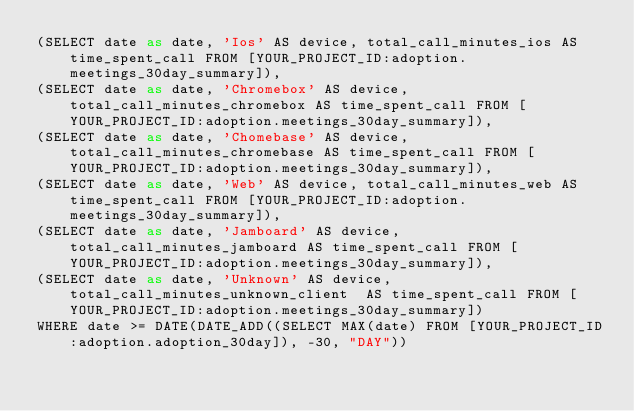Convert code to text. <code><loc_0><loc_0><loc_500><loc_500><_SQL_>(SELECT date as date, 'Ios' AS device, total_call_minutes_ios AS time_spent_call FROM [YOUR_PROJECT_ID:adoption.meetings_30day_summary]),
(SELECT date as date, 'Chromebox' AS device, total_call_minutes_chromebox AS time_spent_call FROM [YOUR_PROJECT_ID:adoption.meetings_30day_summary]),
(SELECT date as date, 'Chomebase' AS device, total_call_minutes_chromebase AS time_spent_call FROM [YOUR_PROJECT_ID:adoption.meetings_30day_summary]),
(SELECT date as date, 'Web' AS device, total_call_minutes_web AS time_spent_call FROM [YOUR_PROJECT_ID:adoption.meetings_30day_summary]),
(SELECT date as date, 'Jamboard' AS device, total_call_minutes_jamboard AS time_spent_call FROM [YOUR_PROJECT_ID:adoption.meetings_30day_summary]),
(SELECT date as date, 'Unknown' AS device, total_call_minutes_unknown_client  AS time_spent_call FROM [YOUR_PROJECT_ID:adoption.meetings_30day_summary])
WHERE date >= DATE(DATE_ADD((SELECT MAX(date) FROM [YOUR_PROJECT_ID:adoption.adoption_30day]), -30, "DAY"))</code> 